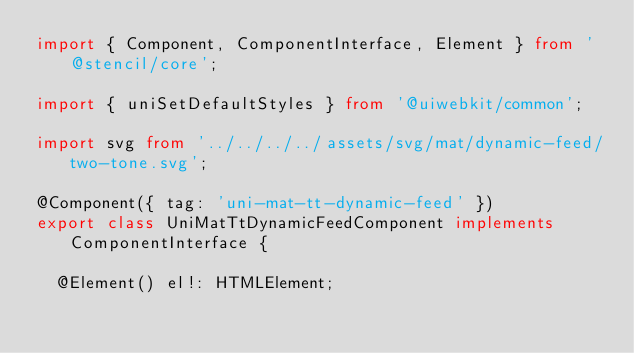Convert code to text. <code><loc_0><loc_0><loc_500><loc_500><_TypeScript_>import { Component, ComponentInterface, Element } from '@stencil/core';

import { uniSetDefaultStyles } from '@uiwebkit/common';

import svg from '../../../../assets/svg/mat/dynamic-feed/two-tone.svg';

@Component({ tag: 'uni-mat-tt-dynamic-feed' })
export class UniMatTtDynamicFeedComponent implements ComponentInterface {

  @Element() el!: HTMLElement;
</code> 